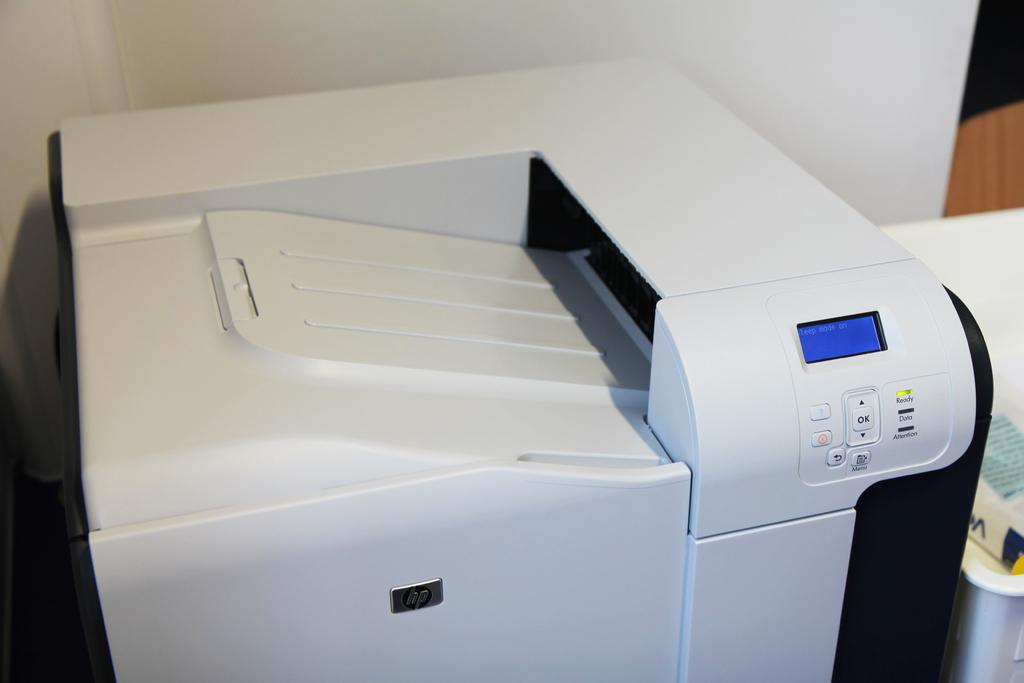<image>
Share a concise interpretation of the image provided. A large printer with the text sleep mode on its screen. 